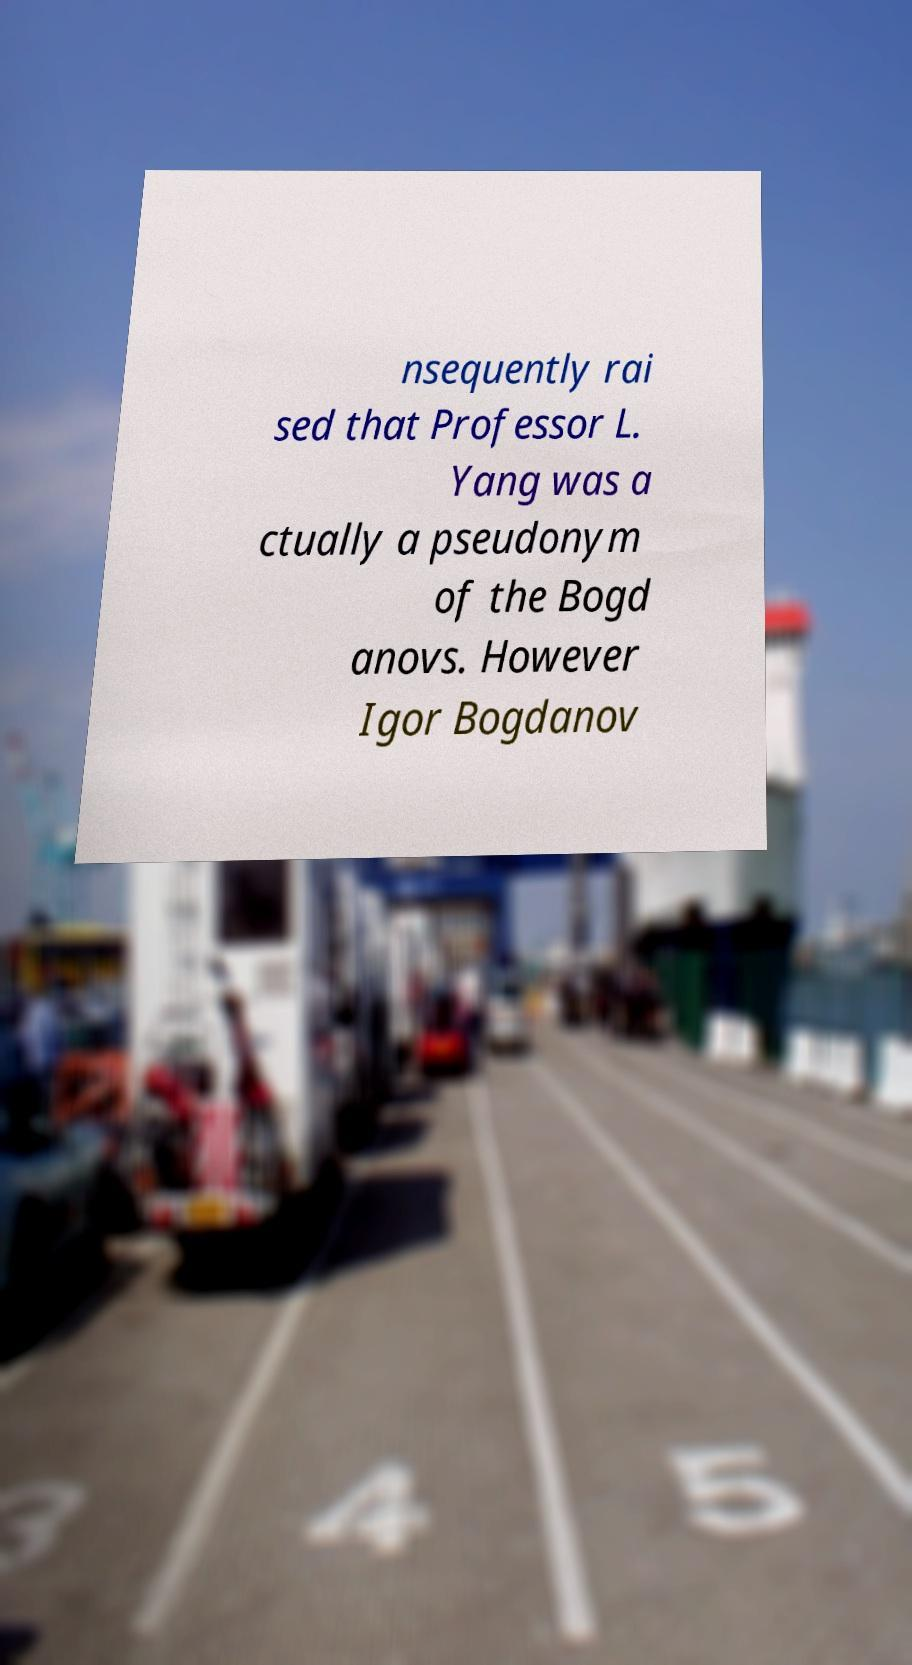Could you assist in decoding the text presented in this image and type it out clearly? nsequently rai sed that Professor L. Yang was a ctually a pseudonym of the Bogd anovs. However Igor Bogdanov 